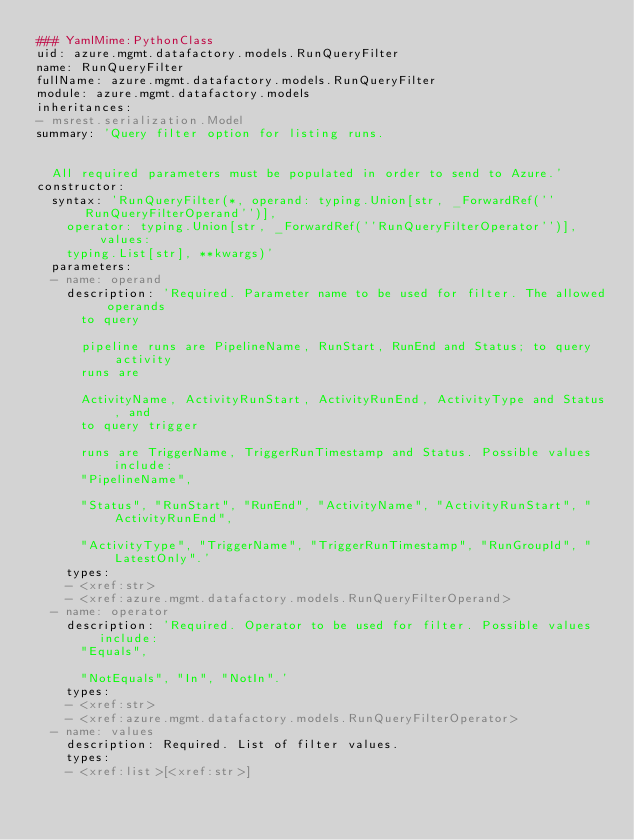Convert code to text. <code><loc_0><loc_0><loc_500><loc_500><_YAML_>### YamlMime:PythonClass
uid: azure.mgmt.datafactory.models.RunQueryFilter
name: RunQueryFilter
fullName: azure.mgmt.datafactory.models.RunQueryFilter
module: azure.mgmt.datafactory.models
inheritances:
- msrest.serialization.Model
summary: 'Query filter option for listing runs.


  All required parameters must be populated in order to send to Azure.'
constructor:
  syntax: 'RunQueryFilter(*, operand: typing.Union[str, _ForwardRef(''RunQueryFilterOperand'')],
    operator: typing.Union[str, _ForwardRef(''RunQueryFilterOperator'')], values:
    typing.List[str], **kwargs)'
  parameters:
  - name: operand
    description: 'Required. Parameter name to be used for filter. The allowed operands
      to query

      pipeline runs are PipelineName, RunStart, RunEnd and Status; to query activity
      runs are

      ActivityName, ActivityRunStart, ActivityRunEnd, ActivityType and Status, and
      to query trigger

      runs are TriggerName, TriggerRunTimestamp and Status. Possible values include:
      "PipelineName",

      "Status", "RunStart", "RunEnd", "ActivityName", "ActivityRunStart", "ActivityRunEnd",

      "ActivityType", "TriggerName", "TriggerRunTimestamp", "RunGroupId", "LatestOnly".'
    types:
    - <xref:str>
    - <xref:azure.mgmt.datafactory.models.RunQueryFilterOperand>
  - name: operator
    description: 'Required. Operator to be used for filter. Possible values include:
      "Equals",

      "NotEquals", "In", "NotIn".'
    types:
    - <xref:str>
    - <xref:azure.mgmt.datafactory.models.RunQueryFilterOperator>
  - name: values
    description: Required. List of filter values.
    types:
    - <xref:list>[<xref:str>]
</code> 